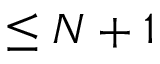Convert formula to latex. <formula><loc_0><loc_0><loc_500><loc_500>\leq N + 1</formula> 